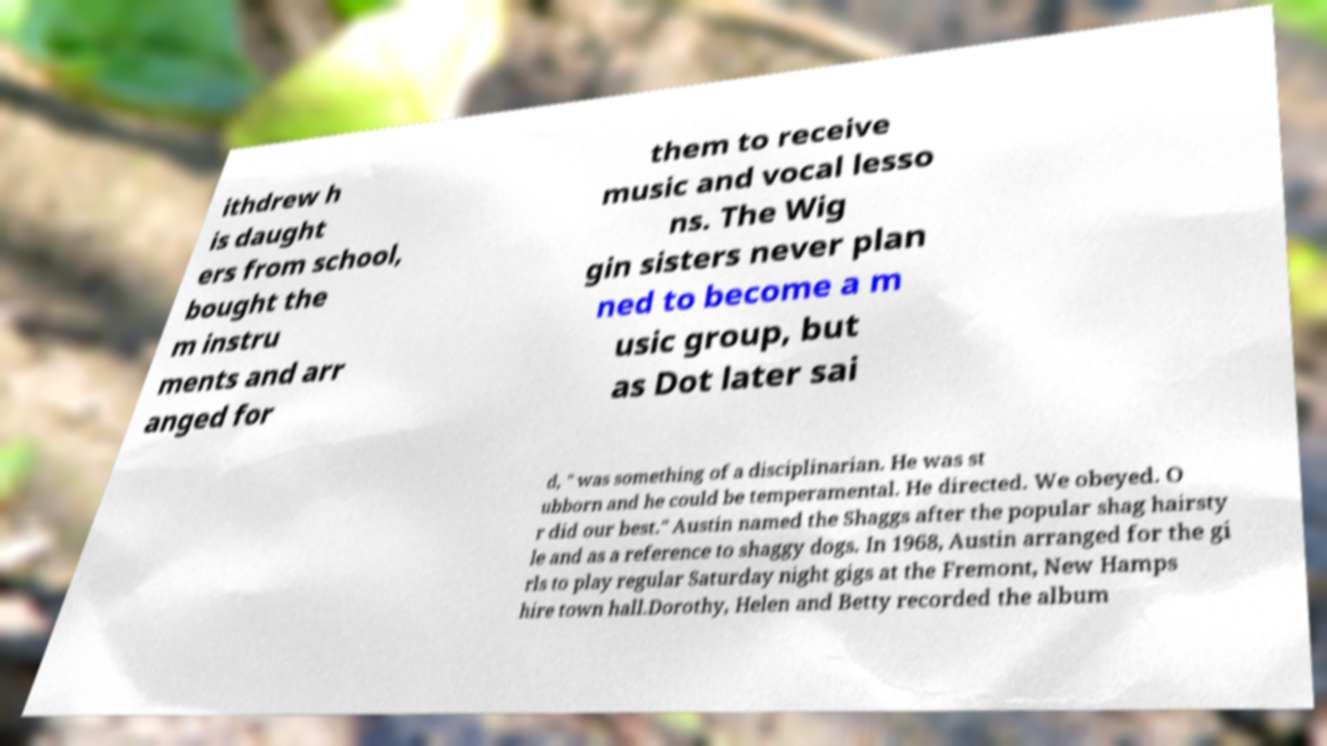For documentation purposes, I need the text within this image transcribed. Could you provide that? ithdrew h is daught ers from school, bought the m instru ments and arr anged for them to receive music and vocal lesso ns. The Wig gin sisters never plan ned to become a m usic group, but as Dot later sai d, " was something of a disciplinarian. He was st ubborn and he could be temperamental. He directed. We obeyed. O r did our best." Austin named the Shaggs after the popular shag hairsty le and as a reference to shaggy dogs. In 1968, Austin arranged for the gi rls to play regular Saturday night gigs at the Fremont, New Hamps hire town hall.Dorothy, Helen and Betty recorded the album 